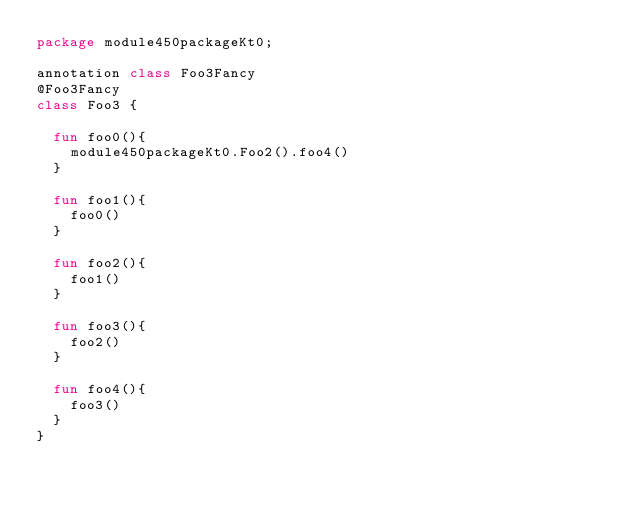Convert code to text. <code><loc_0><loc_0><loc_500><loc_500><_Kotlin_>package module450packageKt0;

annotation class Foo3Fancy
@Foo3Fancy
class Foo3 {

  fun foo0(){
    module450packageKt0.Foo2().foo4()
  }

  fun foo1(){
    foo0()
  }

  fun foo2(){
    foo1()
  }

  fun foo3(){
    foo2()
  }

  fun foo4(){
    foo3()
  }
}</code> 